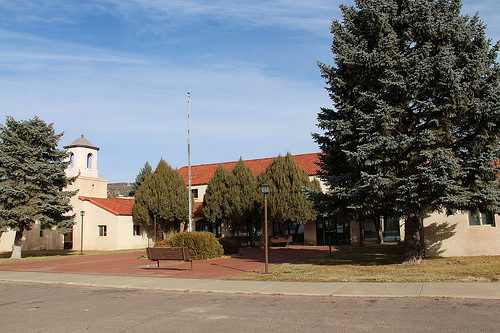<image>
Is there a building behind the tree? Yes. From this viewpoint, the building is positioned behind the tree, with the tree partially or fully occluding the building. Is there a tree in front of the house? Yes. The tree is positioned in front of the house, appearing closer to the camera viewpoint. 